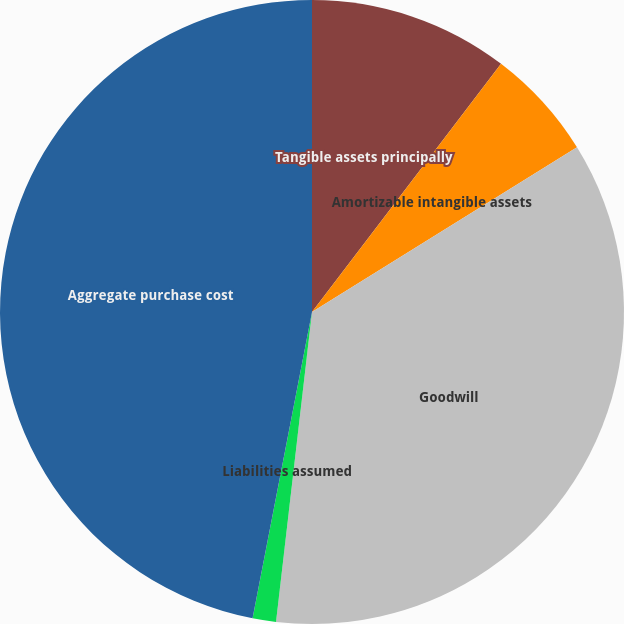Convert chart to OTSL. <chart><loc_0><loc_0><loc_500><loc_500><pie_chart><fcel>Tangible assets principally<fcel>Amortizable intangible assets<fcel>Goodwill<fcel>Liabilities assumed<fcel>Aggregate purchase cost<nl><fcel>10.36%<fcel>5.79%<fcel>35.69%<fcel>1.21%<fcel>46.95%<nl></chart> 